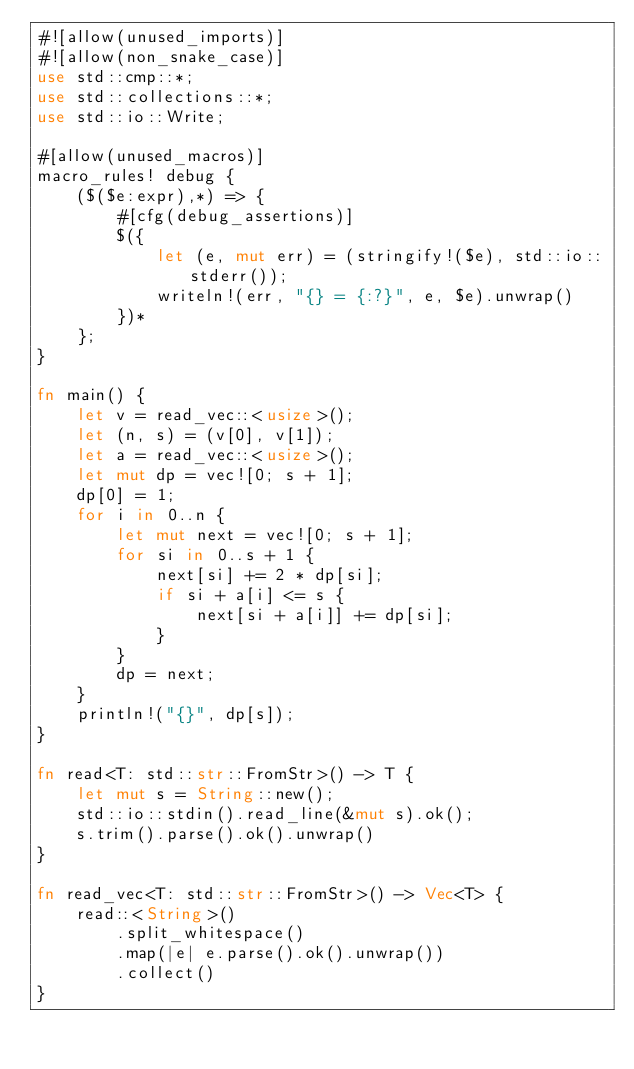<code> <loc_0><loc_0><loc_500><loc_500><_Rust_>#![allow(unused_imports)]
#![allow(non_snake_case)]
use std::cmp::*;
use std::collections::*;
use std::io::Write;

#[allow(unused_macros)]
macro_rules! debug {
    ($($e:expr),*) => {
        #[cfg(debug_assertions)]
        $({
            let (e, mut err) = (stringify!($e), std::io::stderr());
            writeln!(err, "{} = {:?}", e, $e).unwrap()
        })*
    };
}

fn main() {
    let v = read_vec::<usize>();
    let (n, s) = (v[0], v[1]);
    let a = read_vec::<usize>();
    let mut dp = vec![0; s + 1];
    dp[0] = 1;
    for i in 0..n {
        let mut next = vec![0; s + 1];
        for si in 0..s + 1 {
            next[si] += 2 * dp[si];
            if si + a[i] <= s {
                next[si + a[i]] += dp[si];
            }
        }
        dp = next;
    }
    println!("{}", dp[s]);
}

fn read<T: std::str::FromStr>() -> T {
    let mut s = String::new();
    std::io::stdin().read_line(&mut s).ok();
    s.trim().parse().ok().unwrap()
}

fn read_vec<T: std::str::FromStr>() -> Vec<T> {
    read::<String>()
        .split_whitespace()
        .map(|e| e.parse().ok().unwrap())
        .collect()
}
</code> 